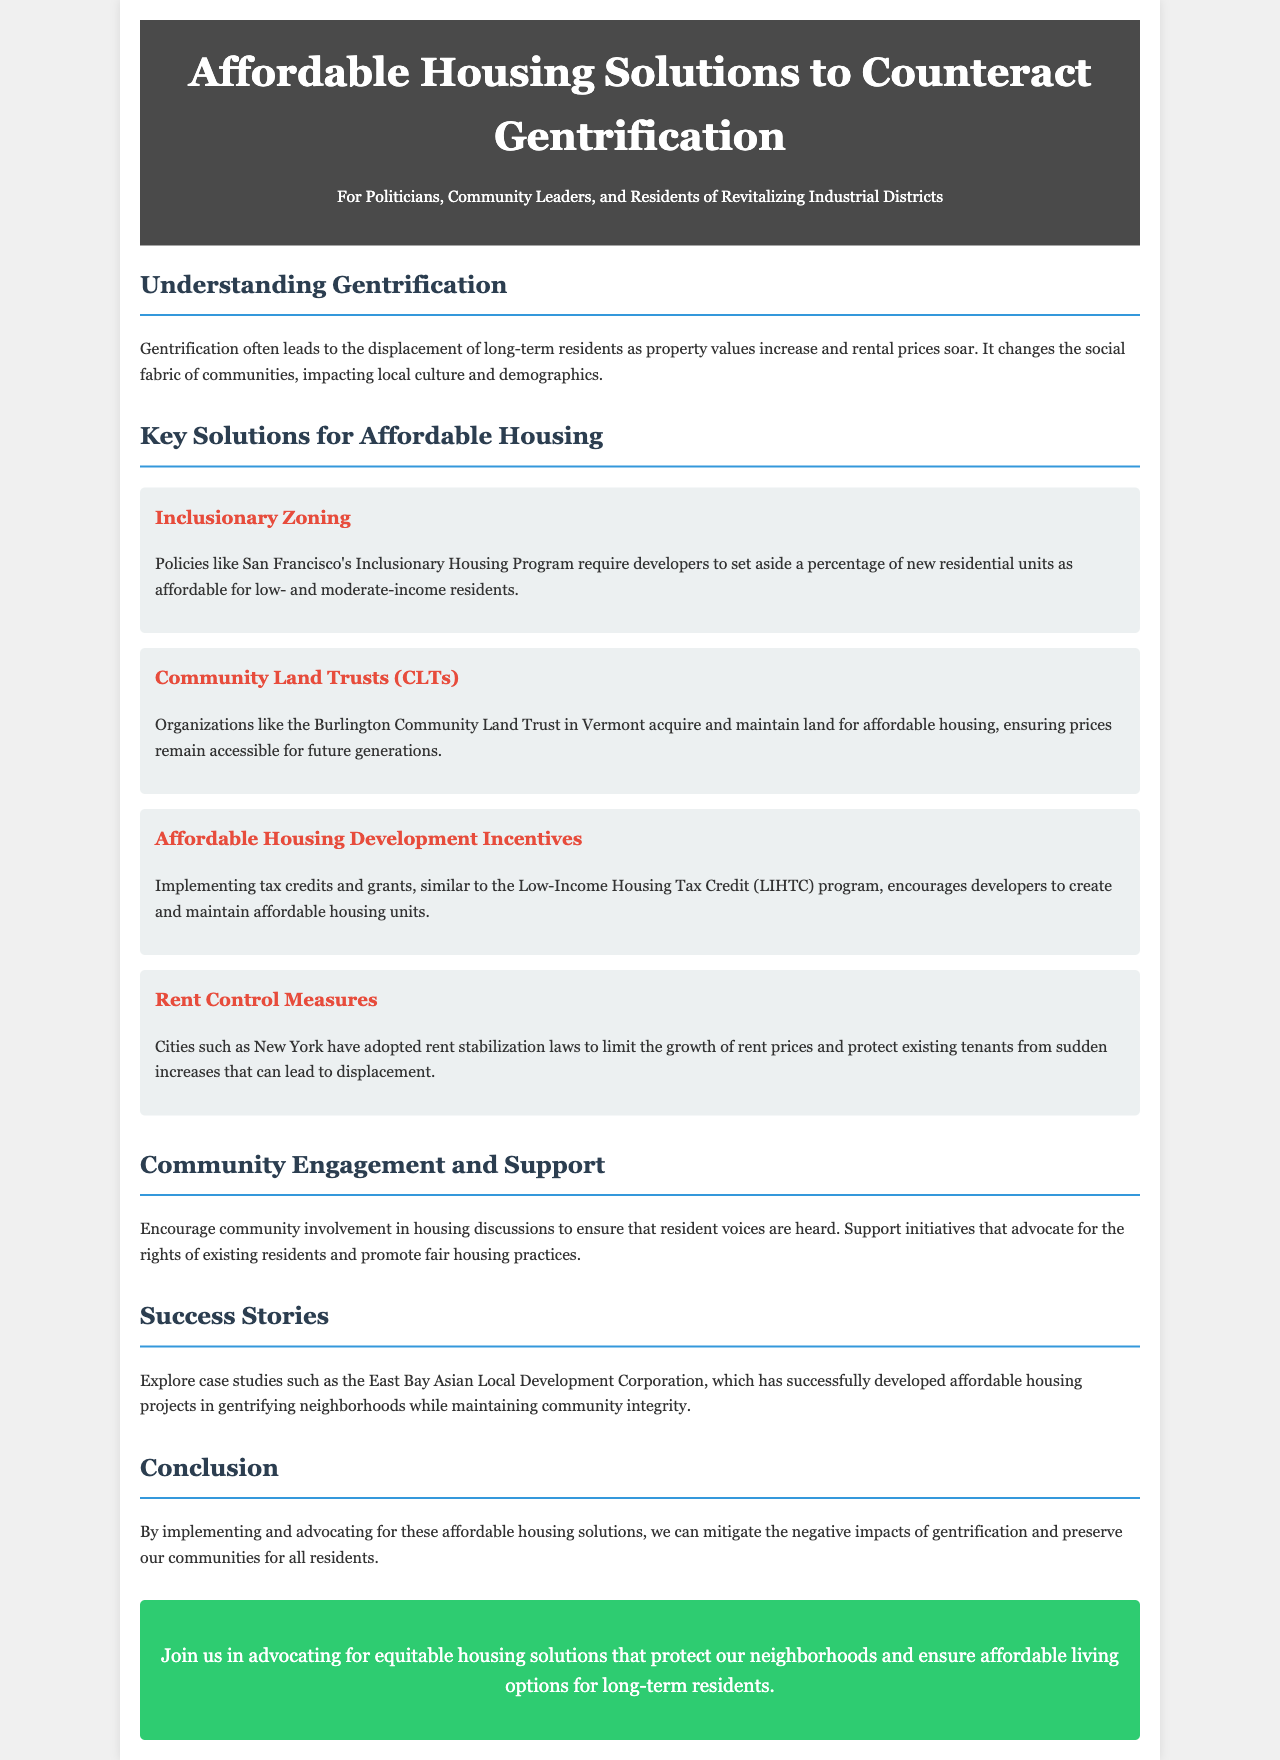What is the title of the document? The title is prominently displayed at the top of the brochure.
Answer: Affordable Housing Solutions to Counteract Gentrification What is one impact of gentrification mentioned? The document states one consequence of gentrification.
Answer: Displacement of long-term residents What is an example of a housing solution discussed? The document lists various housing solutions under the key solutions section.
Answer: Inclusionary Zoning What program encourages developers to create affordable housing? The brochure mentions specific incentives for affordable housing development.
Answer: Low-Income Housing Tax Credit Which city adopted rent stabilization laws? The document provides an example of a city with rent control measures in place.
Answer: New York What type of organization maintains land for affordable housing? The document describes a specific organizational model for ensuring affordable housing.
Answer: Community Land Trusts (CLTs) What is the goal of community engagement according to the document? The document emphasizes the importance of resident involvement in housing discussions.
Answer: Ensure resident voices are heard Which corporation is highlighted for successful affordable housing projects? The success stories section mentions a specific organization involved in housing development.
Answer: East Bay Asian Local Development Corporation What is the call to action at the end of the document? The brochure concludes with a statement encouraging advocacy.
Answer: Advocate for equitable housing solutions 